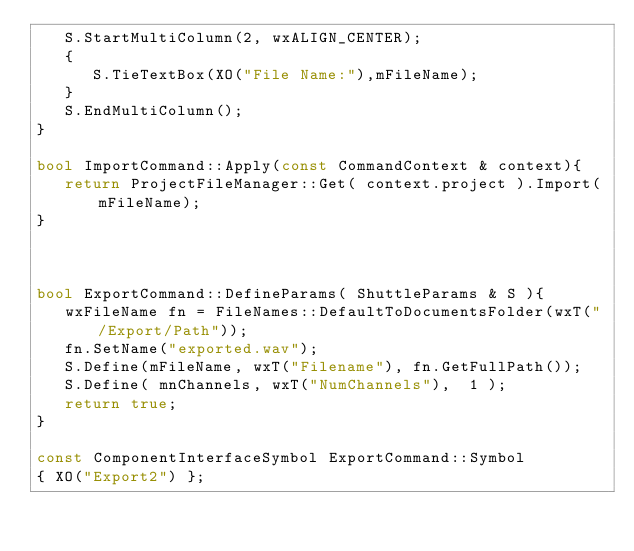<code> <loc_0><loc_0><loc_500><loc_500><_C++_>   S.StartMultiColumn(2, wxALIGN_CENTER);
   {
      S.TieTextBox(XO("File Name:"),mFileName);
   }
   S.EndMultiColumn();
}

bool ImportCommand::Apply(const CommandContext & context){
   return ProjectFileManager::Get( context.project ).Import(mFileName);
}



bool ExportCommand::DefineParams( ShuttleParams & S ){
   wxFileName fn = FileNames::DefaultToDocumentsFolder(wxT("/Export/Path"));
   fn.SetName("exported.wav");
   S.Define(mFileName, wxT("Filename"), fn.GetFullPath());
   S.Define( mnChannels, wxT("NumChannels"),  1 );
   return true;
}

const ComponentInterfaceSymbol ExportCommand::Symbol
{ XO("Export2") };
</code> 